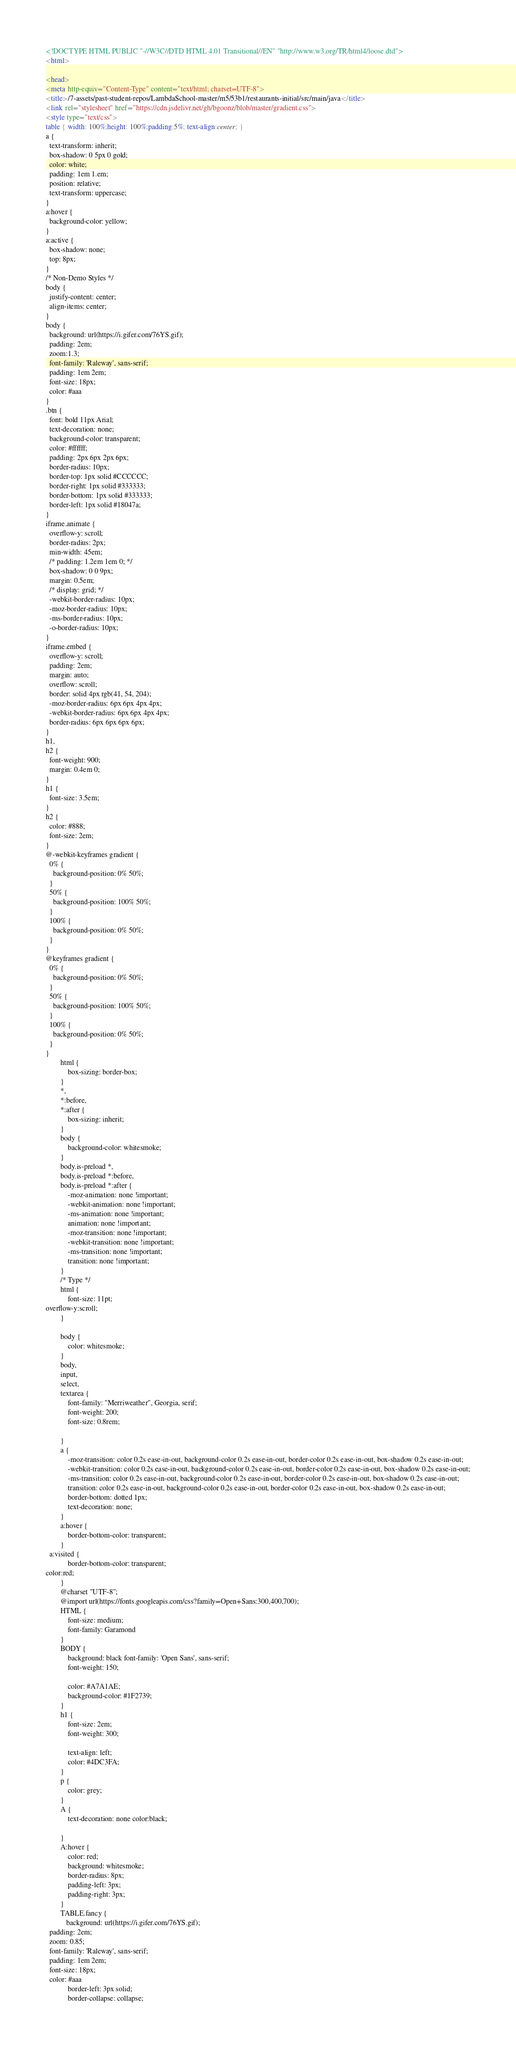<code> <loc_0><loc_0><loc_500><loc_500><_HTML_><!DOCTYPE HTML PUBLIC "-//W3C//DTD HTML 4.01 Transitional//EN" "http://www.w3.org/TR/html4/loose.dtd">
<html>

<head>
<meta http-equiv="Content-Type" content="text/html; charset=UTF-8">
<title>/7-assets/past-student-repos/LambdaSchool-master/m5/53b1/restaurants-initial/src/main/java</title>
<link rel="stylesheet" href="https://cdn.jsdelivr.net/gh/bgoonz/blob/master/gradient.css">
<style type="text/css">
table { width: 100%;height: 100%;padding:5%; text-align:center; }
a {
  text-transform: inherit;
  box-shadow: 0 5px 0 gold;
  color: white;
  padding: 1em 1.em;
  position: relative;
  text-transform: uppercase;
}
a:hover {
  background-color: yellow;
}
a:active {
  box-shadow: none;
  top: 8px;
}
/* Non-Demo Styles */
body {
  justify-content: center;
  align-items: center;
}
body {
  background: url(https://i.gifer.com/76YS.gif);
  padding: 2em;
  zoom:1.3;
  font-family: 'Raleway', sans-serif;
  padding: 1em 2em;
  font-size: 18px;
  color: #aaa
}
.btn {
  font: bold 11px Arial;
  text-decoration: none;
  background-color: transparent;
  color: #ffffff;
  padding: 2px 6px 2px 6px;
  border-radius: 10px;
  border-top: 1px solid #CCCCCC;
  border-right: 1px solid #333333;
  border-bottom: 1px solid #333333;
  border-left: 1px solid #18047a;
}
iframe.animate {
  overflow-y: scroll;
  border-radius: 2px;
  min-width: 45em;
  /* padding: 1.2em 1em 0; */
  box-shadow: 0 0 9px;
  margin: 0.5em;
  /* display: grid; */
  -webkit-border-radius: 10px;
  -moz-border-radius: 10px;
  -ms-border-radius: 10px;
  -o-border-radius: 10px;
}
iframe.embed {
  overflow-y: scroll;
  padding: 2em;
  margin: auto;
  overflow: scroll;
  border: solid 4px rgb(41, 54, 204);
  -moz-border-radius: 6px 6px 4px 4px;
  -webkit-border-radius: 6px 6px 4px 4px;
  border-radius: 6px 6px 6px 6px;
}
h1,
h2 {
  font-weight: 900;
  margin: 0.4em 0;
}
h1 {
  font-size: 3.5em;
}
h2 {
  color: #888;
  font-size: 2em;
}
@-webkit-keyframes gradient {
  0% {
    background-position: 0% 50%;
  }
  50% {
    background-position: 100% 50%;
  }
  100% {
    background-position: 0% 50%;
  }
}
@keyframes gradient {
  0% {
    background-position: 0% 50%;
  }
  50% {
    background-position: 100% 50%;
  }
  100% {
    background-position: 0% 50%;
  }
}
        html {
            box-sizing: border-box;
        }
        *,
        *:before,
        *:after {
            box-sizing: inherit;
        }
        body {
            background-color: whitesmoke;
        }
        body.is-preload *,
        body.is-preload *:before,
        body.is-preload *:after {
            -moz-animation: none !important;
            -webkit-animation: none !important;
            -ms-animation: none !important;
            animation: none !important;
            -moz-transition: none !important;
            -webkit-transition: none !important;
            -ms-transition: none !important;
            transition: none !important;
        }
        /* Type */
        html {
            font-size: 11pt;
overflow-y:scroll;
        }
       
        body {
            color: whitesmoke;
        }
        body,
        input,
        select,
        textarea {
            font-family: "Merriweather", Georgia, serif;
            font-weight: 200;
            font-size: 0.8rem;
          
        }
        a {
            -moz-transition: color 0.2s ease-in-out, background-color 0.2s ease-in-out, border-color 0.2s ease-in-out, box-shadow 0.2s ease-in-out;
            -webkit-transition: color 0.2s ease-in-out, background-color 0.2s ease-in-out, border-color 0.2s ease-in-out, box-shadow 0.2s ease-in-out;
            -ms-transition: color 0.2s ease-in-out, background-color 0.2s ease-in-out, border-color 0.2s ease-in-out, box-shadow 0.2s ease-in-out;
            transition: color 0.2s ease-in-out, background-color 0.2s ease-in-out, border-color 0.2s ease-in-out, box-shadow 0.2s ease-in-out;
            border-bottom: dotted 1px;
            text-decoration: none;
        }
        a:hover {
            border-bottom-color: transparent;
        }
  a:visited {
            border-bottom-color: transparent;
color:red;
        }
        @charset "UTF-8";
        @import url(https://fonts.googleapis.com/css?family=Open+Sans:300,400,700);
        HTML {
            font-size: medium;
            font-family: Garamond
        }
        BODY {
            background: black font-family: 'Open Sans', sans-serif;
            font-weight: 150;
         
            color: #A7A1AE;
            background-color: #1F2739;
        }
        h1 {
            font-size: 2em;
            font-weight: 300;
         
            text-align: left;
            color: #4DC3FA;
        }
        p {
            color: grey;
        }
        A {
            text-decoration: none color:black;
          
        }
        A:hover {
            color: red;
            background: whitesmoke;
            border-radius: 8px;
            padding-left: 3px;
            padding-right: 3px;
        }
        TABLE.fancy {
           background: url(https://i.gifer.com/76YS.gif);
  padding: 2em;
  zoom: 0.85;
  font-family: 'Raleway', sans-serif;
  padding: 1em 2em;
  font-size: 18px;
  color: #aaa
            border-left: 3px solid;
            border-collapse: collapse;</code> 